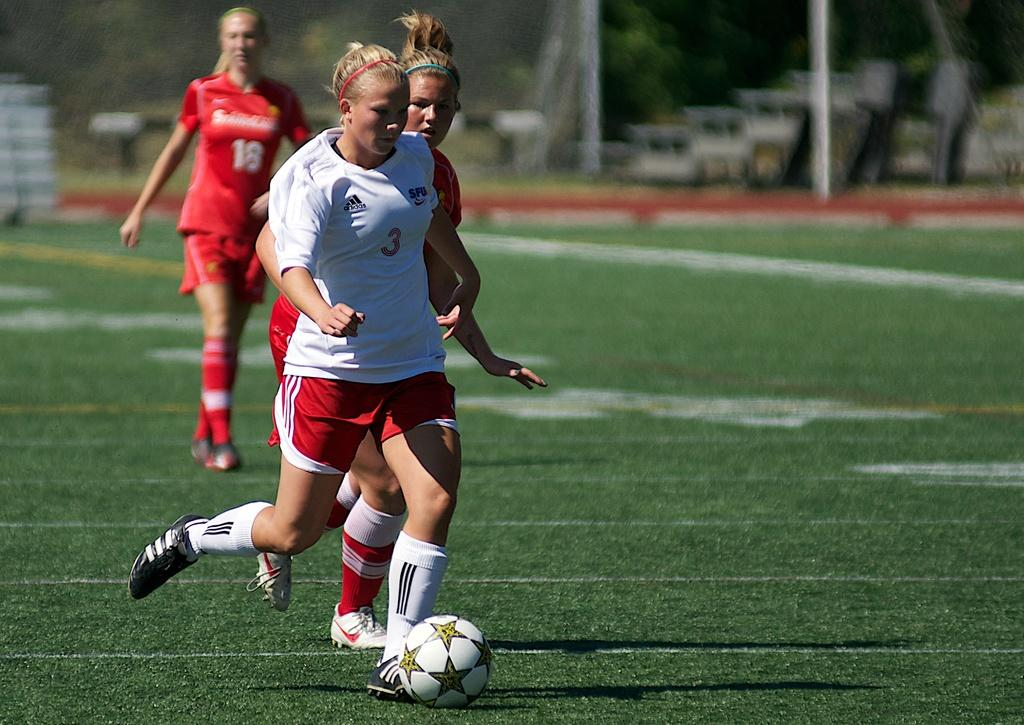What is happening in the image involving a group of girls? The girls are playing football in the image. What type of surface is the football game being played on? The football game is taking place on a grass floor. What can be seen in the background of the image? There are trees around the area in the image. What kind of location does the image suggest? The setting appears to be a playground. What type of yarn is being used by the girls to play football in the image? There is no yarn present in the image; the girls are playing football with a football. Are the girls wearing stockings while playing football in the image? The image does not provide information about the girls' clothing, so it cannot be determined if they are wearing stockings. 